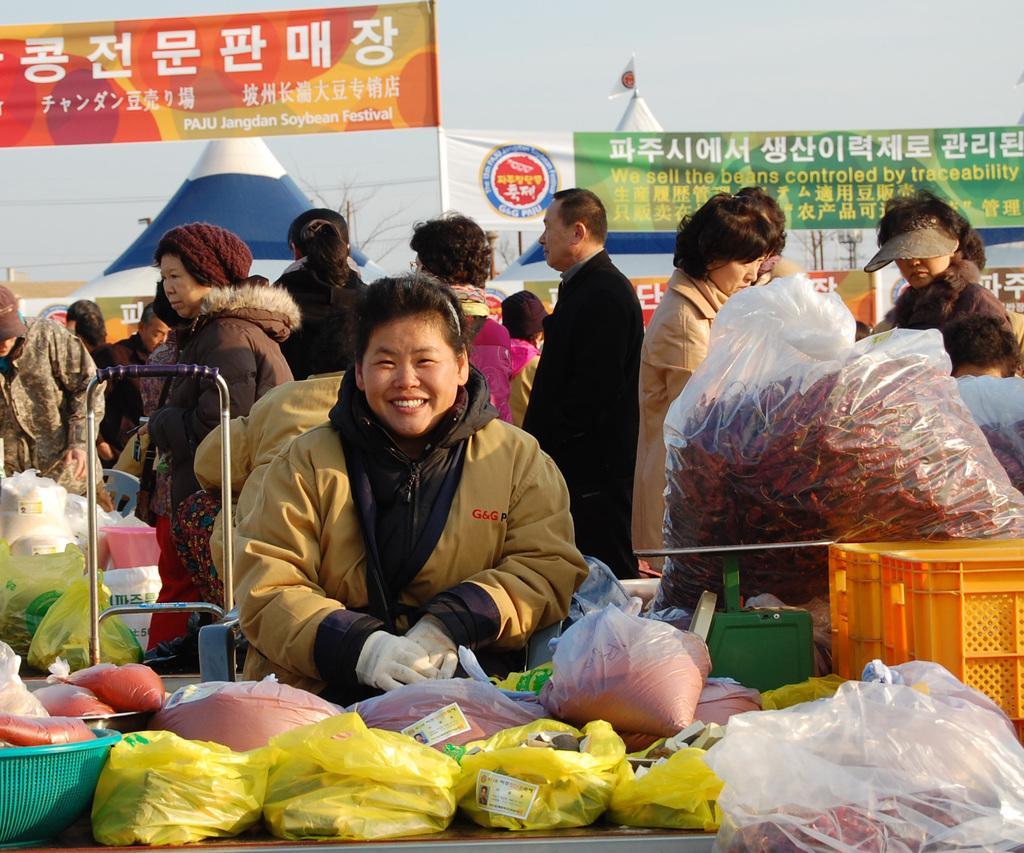In one or two sentences, can you explain what this image depicts? In this image I can see the group of people with different color dresses. In-front of few people I can see few items in the plastic covers. I can see the baskets and bowl. In the background I can see the banners, boards, tents, poles and the sky. 